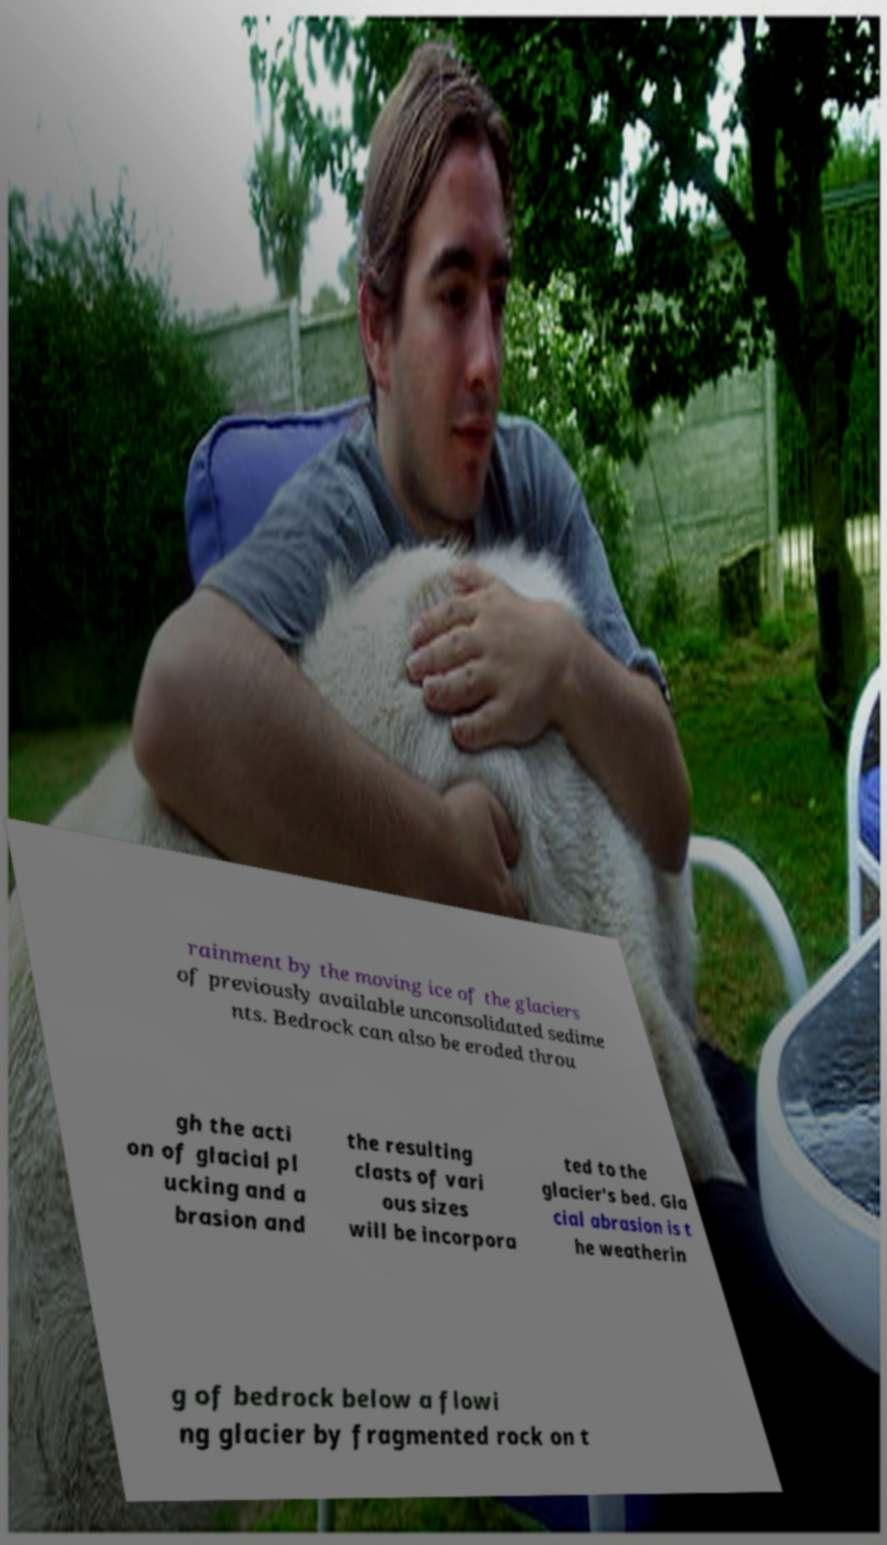Can you read and provide the text displayed in the image?This photo seems to have some interesting text. Can you extract and type it out for me? rainment by the moving ice of the glaciers of previously available unconsolidated sedime nts. Bedrock can also be eroded throu gh the acti on of glacial pl ucking and a brasion and the resulting clasts of vari ous sizes will be incorpora ted to the glacier's bed. Gla cial abrasion is t he weatherin g of bedrock below a flowi ng glacier by fragmented rock on t 